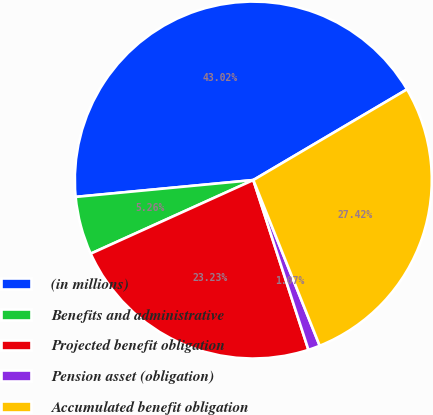Convert chart to OTSL. <chart><loc_0><loc_0><loc_500><loc_500><pie_chart><fcel>(in millions)<fcel>Benefits and administrative<fcel>Projected benefit obligation<fcel>Pension asset (obligation)<fcel>Accumulated benefit obligation<nl><fcel>43.02%<fcel>5.26%<fcel>23.23%<fcel>1.07%<fcel>27.42%<nl></chart> 